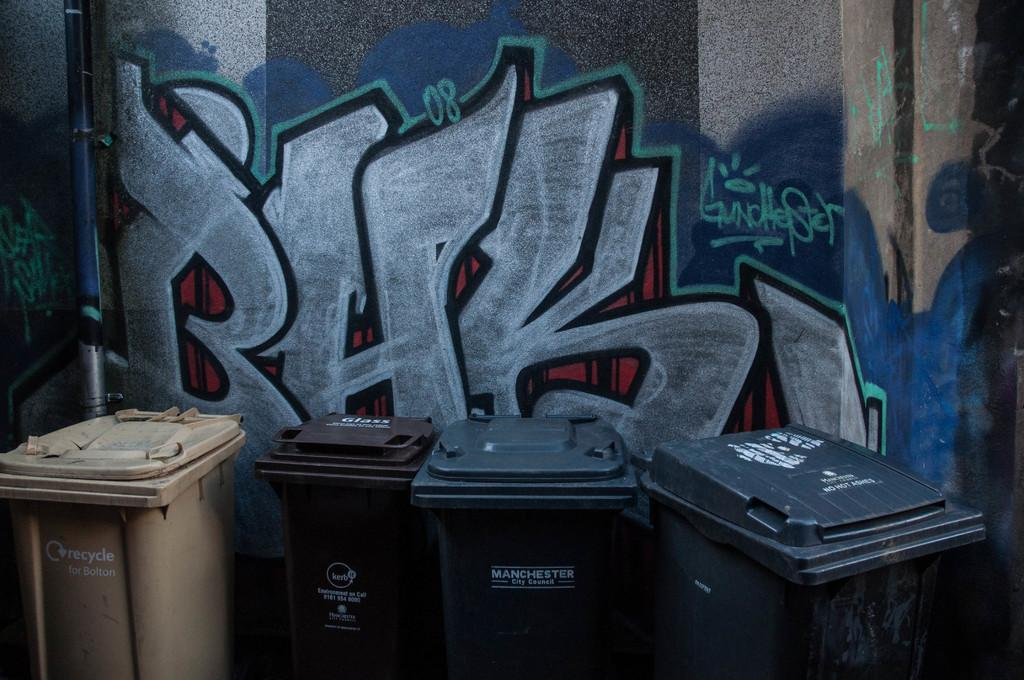<image>
Relay a brief, clear account of the picture shown. Trash bins in front of graffiti with one mentioning the Manchester city council. 